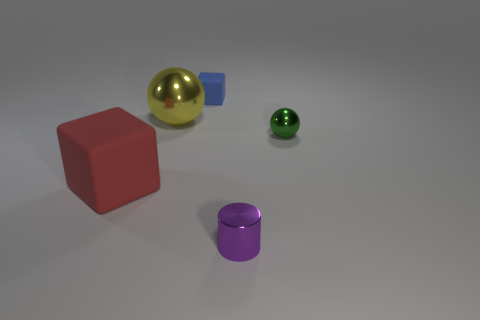Add 5 tiny purple things. How many objects exist? 10 Subtract all blue blocks. How many blocks are left? 1 Subtract all blue blocks. Subtract all cyan cylinders. How many blocks are left? 1 Subtract all red blocks. How many yellow spheres are left? 1 Subtract all small brown metal cylinders. Subtract all small blue blocks. How many objects are left? 4 Add 3 big objects. How many big objects are left? 5 Add 4 brown cylinders. How many brown cylinders exist? 4 Subtract 0 brown blocks. How many objects are left? 5 Subtract all balls. How many objects are left? 3 Subtract 1 spheres. How many spheres are left? 1 